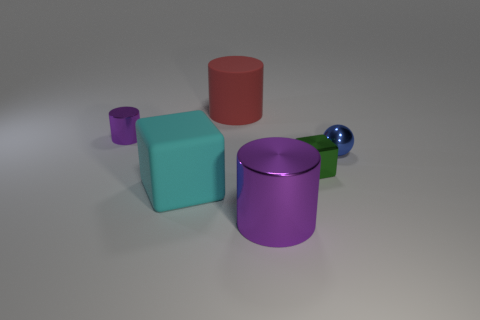There is a cylinder that is right of the red thing; does it have the same color as the small metallic cylinder?
Provide a succinct answer. Yes. What is the tiny cylinder made of?
Give a very brief answer. Metal. There is a big purple cylinder; are there any small spheres in front of it?
Offer a terse response. No. The cyan cube that is made of the same material as the big red cylinder is what size?
Ensure brevity in your answer.  Large. How many large objects have the same color as the matte cube?
Keep it short and to the point. 0. Is the number of green objects that are behind the small metal sphere less than the number of tiny metal objects on the left side of the tiny green metallic thing?
Make the answer very short. Yes. What size is the cube to the left of the large purple shiny cylinder?
Offer a very short reply. Large. There is another cylinder that is the same color as the tiny metallic cylinder; what is its size?
Provide a succinct answer. Large. Is there a purple thing that has the same material as the red thing?
Give a very brief answer. No. Do the tiny green thing and the large cyan object have the same material?
Ensure brevity in your answer.  No. 